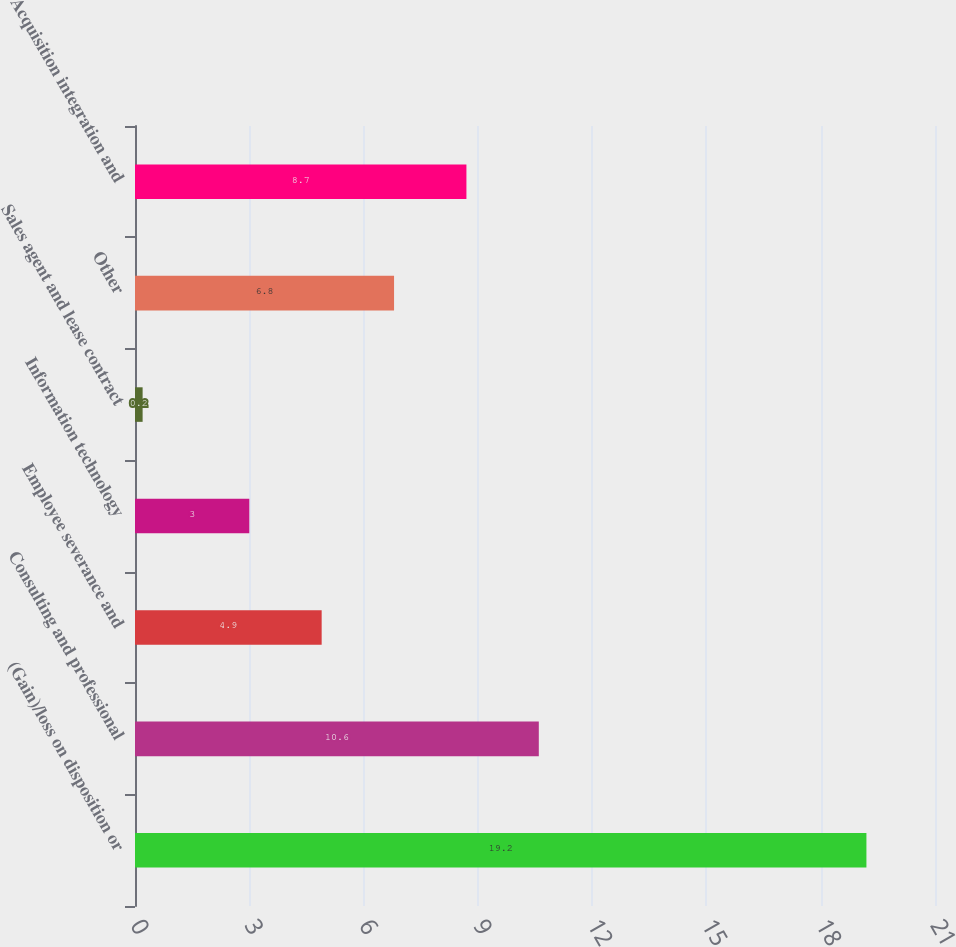Convert chart. <chart><loc_0><loc_0><loc_500><loc_500><bar_chart><fcel>(Gain)/loss on disposition or<fcel>Consulting and professional<fcel>Employee severance and<fcel>Information technology<fcel>Sales agent and lease contract<fcel>Other<fcel>Acquisition integration and<nl><fcel>19.2<fcel>10.6<fcel>4.9<fcel>3<fcel>0.2<fcel>6.8<fcel>8.7<nl></chart> 